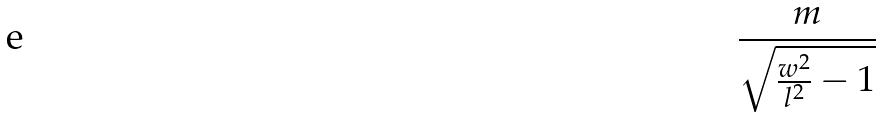Convert formula to latex. <formula><loc_0><loc_0><loc_500><loc_500>\frac { m } { \sqrt { \frac { w ^ { 2 } } { l ^ { 2 } } - 1 } }</formula> 